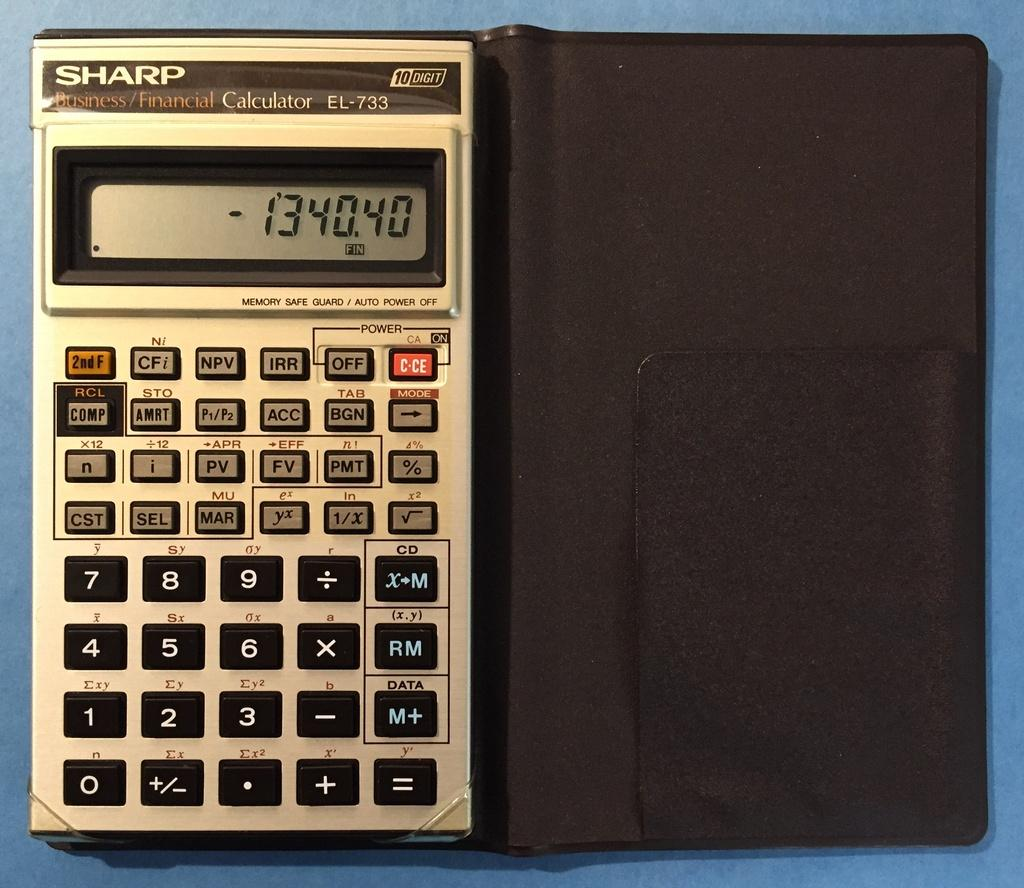<image>
Render a clear and concise summary of the photo. a calculator with the word sharp on it 